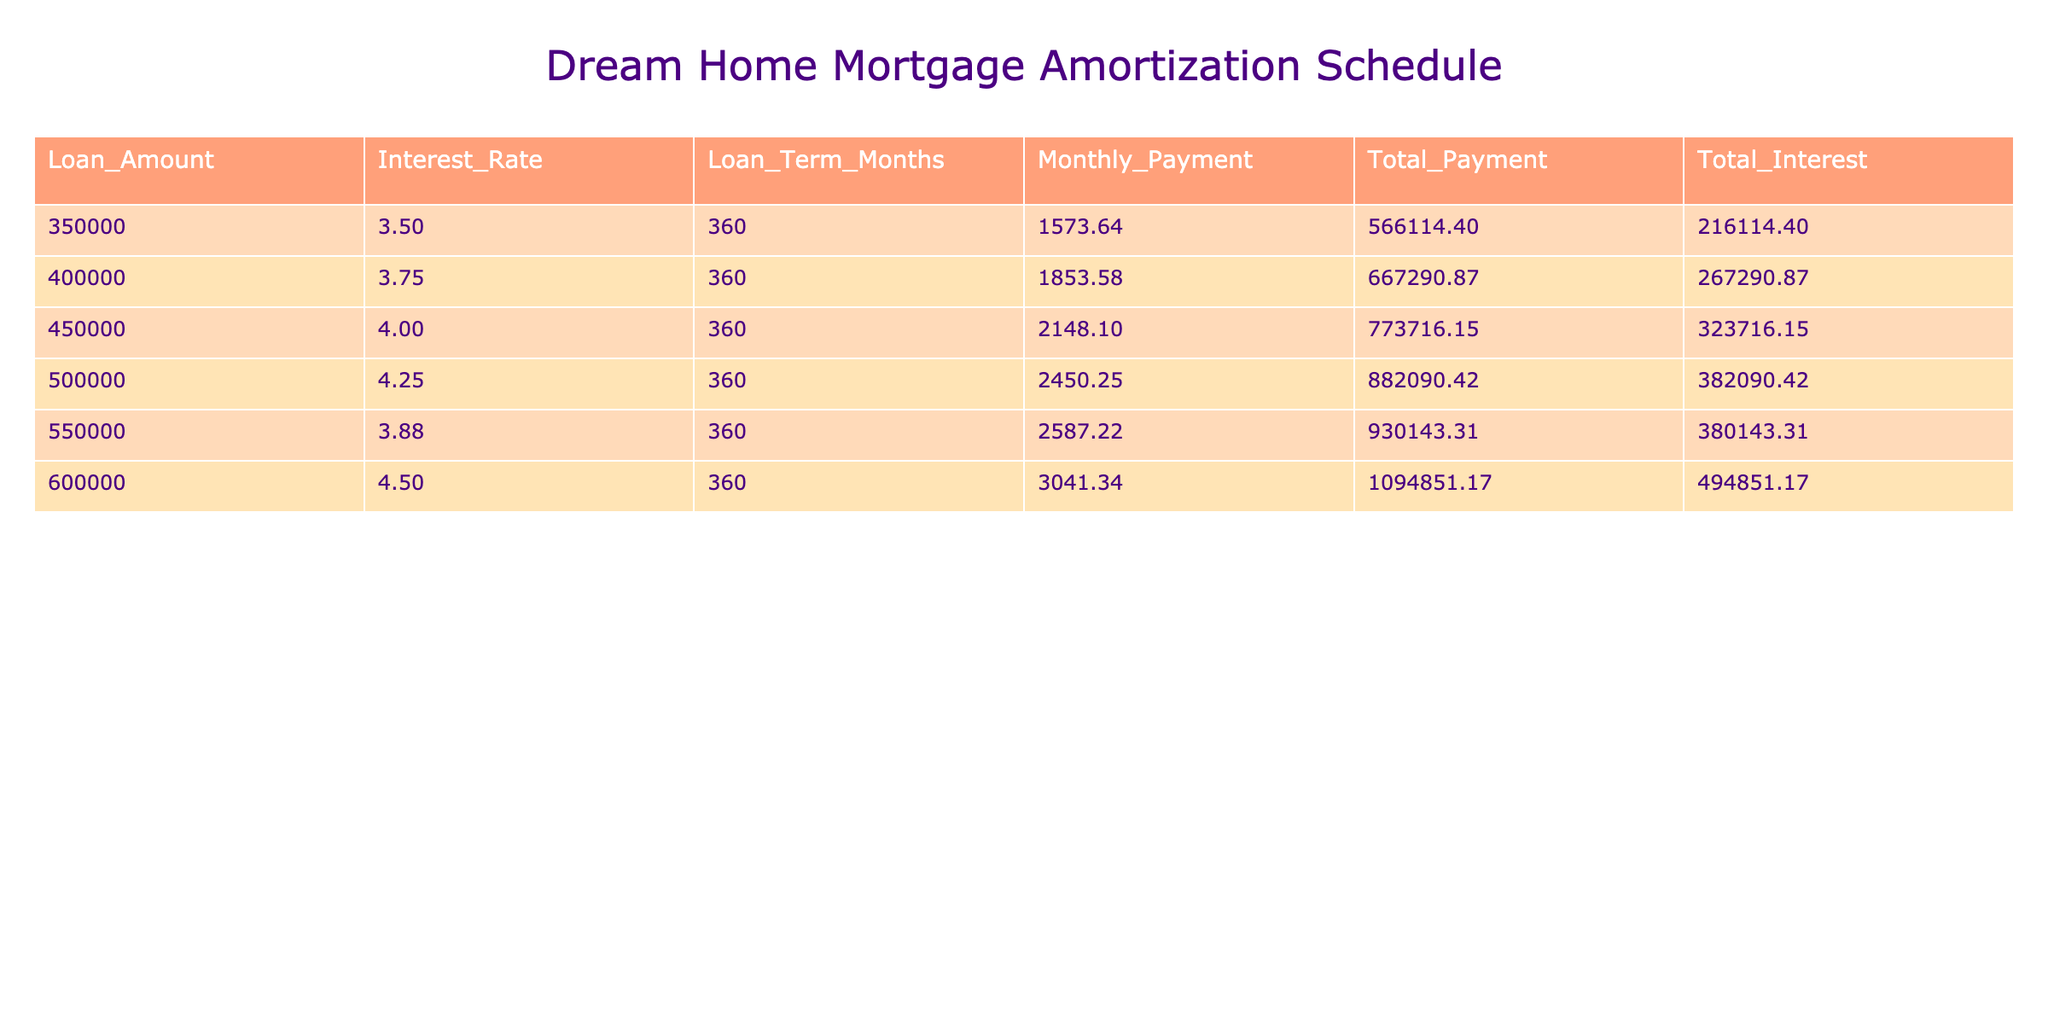What is the total interest for a loan amount of 450,000? Looking at the row where the loan amount is 450,000, the total interest is listed as 323,716.15.
Answer: 323,716.15 What is the monthly payment for a loan amount of 600,000? In the row for the loan amount of 600,000, the monthly payment is specified as 3,041.34.
Answer: 3,041.34 Which loan amount results in the lowest total payment? The total payments for each loan amount can be compared. The lowest total payment is for the loan amount of 350,000, which totals 566,114.40.
Answer: 350,000 What is the average monthly payment across all loan amounts? The monthly payments are 1,573.64, 1,853.58, 2,148.10, 2,450.25, 2,587.22, and 3,041.34. The sum of these payments is 13,254.23, and dividing by 6 gives an average of 2,209.04.
Answer: 2,209.04 Is the total payment for a loan of 500,000 greater than 800,000? The total payment for the loan of 500,000 is 882,090.42, which is indeed greater than 800,000.
Answer: Yes What is the difference in total interest between the loans of 400,000 and 500,000? The total interest for the loan of 400,000 is 267,290.87, and for 500,000 it is 382,090.42. To find the difference, we calculate 382,090.42 - 267,290.87 = 114,799.55.
Answer: 114,799.55 If the interest rate increases by 0.5% across all loans, which loan amount would have the highest monthly payment after the increase? Based on the given table, the loan amount of 600,000 currently has the highest monthly payment of 3,041.34. An increase in the interest rate would likely increase this amount further. Since it already has the highest payment, it would remain the one with the highest payment.
Answer: 600,000 How much more total interest is paid on a 550,000 loan compared to a 350,000 loan? The total interest for a loan of 550,000 is 380,143.31 and for 350,000 is 216,114.40. The difference is calculated as 380,143.31 - 216,114.40 = 164,028.91.
Answer: 164,028.91 Does a loan of 450,000 result in a total payment of fewer than 800,000? The total payment for the 450,000 loan is 773,716.15, which is less than 800,000.
Answer: Yes 